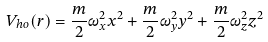<formula> <loc_0><loc_0><loc_500><loc_500>V _ { h o } ( { r } ) = { \frac { m } { 2 } } \omega _ { x } ^ { 2 } x ^ { 2 } + { \frac { m } { 2 } } \omega _ { y } ^ { 2 } y ^ { 2 } + { \frac { m } { 2 } } \omega _ { z } ^ { 2 } z ^ { 2 }</formula> 